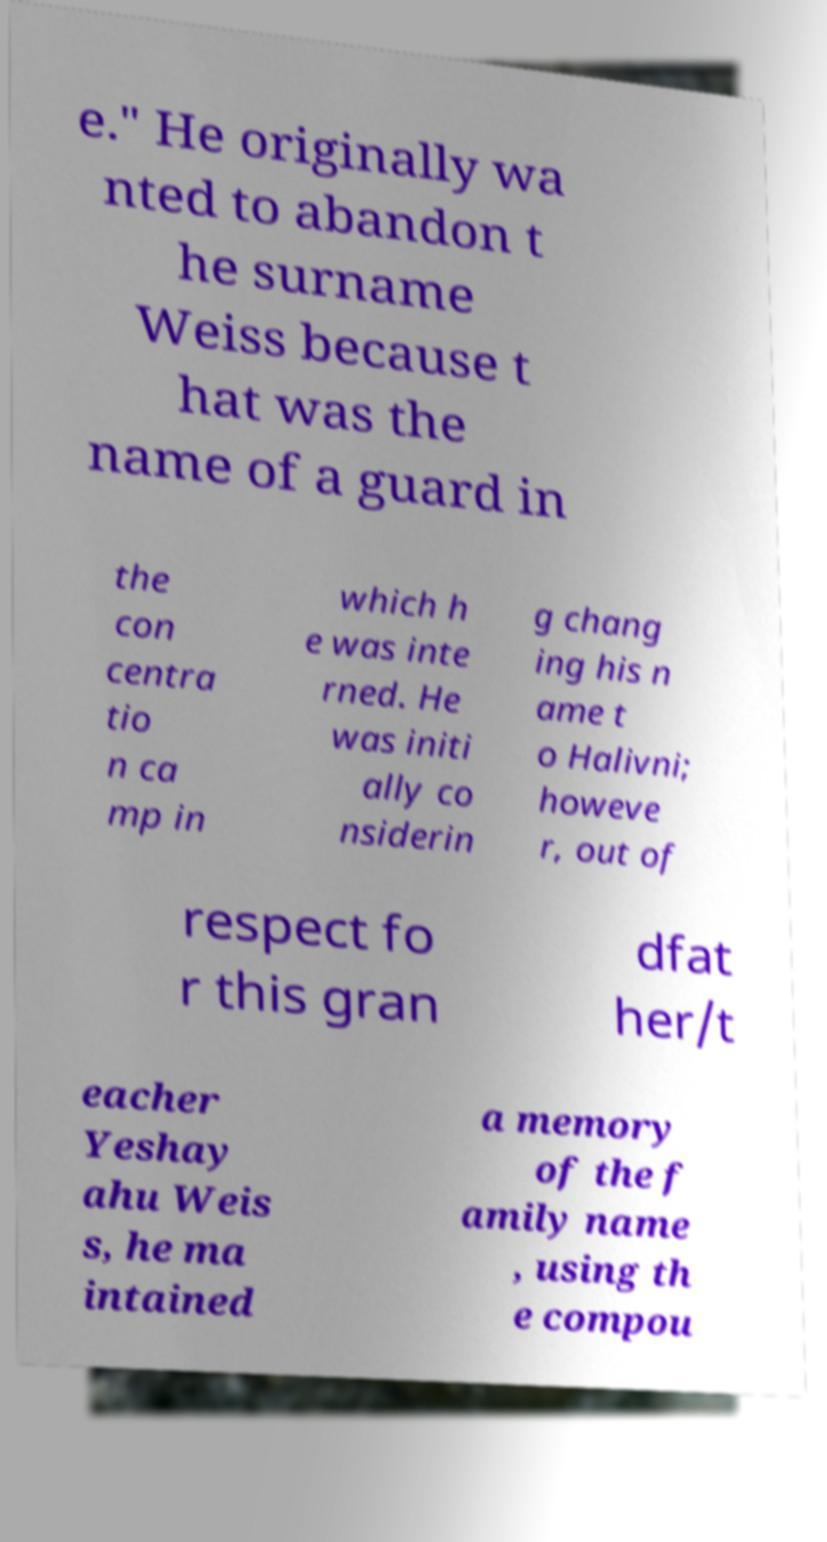Could you assist in decoding the text presented in this image and type it out clearly? e." He originally wa nted to abandon t he surname Weiss because t hat was the name of a guard in the con centra tio n ca mp in which h e was inte rned. He was initi ally co nsiderin g chang ing his n ame t o Halivni; howeve r, out of respect fo r this gran dfat her/t eacher Yeshay ahu Weis s, he ma intained a memory of the f amily name , using th e compou 